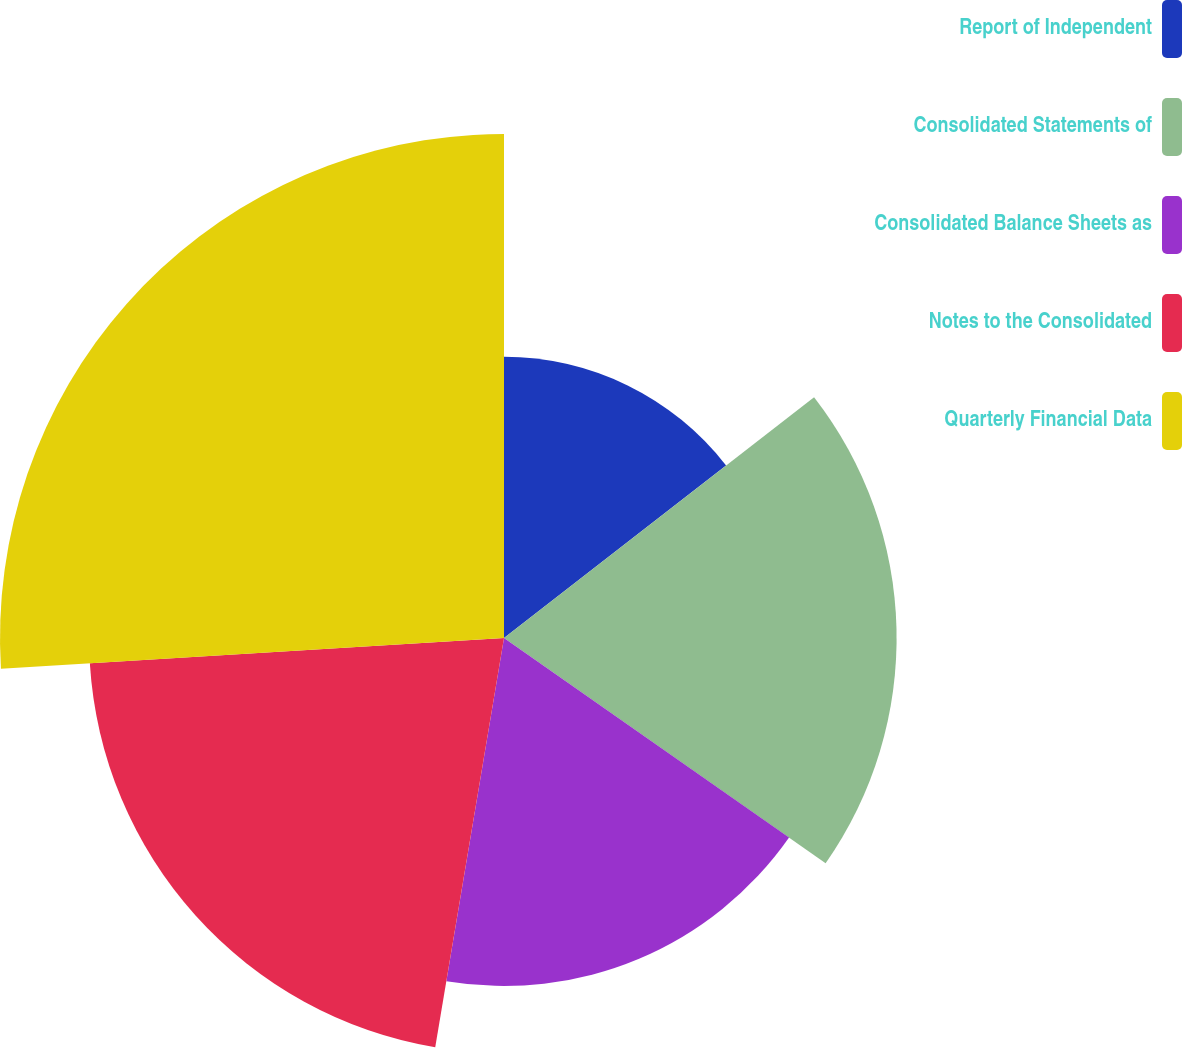Convert chart to OTSL. <chart><loc_0><loc_0><loc_500><loc_500><pie_chart><fcel>Report of Independent<fcel>Consolidated Statements of<fcel>Consolidated Balance Sheets as<fcel>Notes to the Consolidated<fcel>Quarterly Financial Data<nl><fcel>14.49%<fcel>20.23%<fcel>17.93%<fcel>21.38%<fcel>25.97%<nl></chart> 